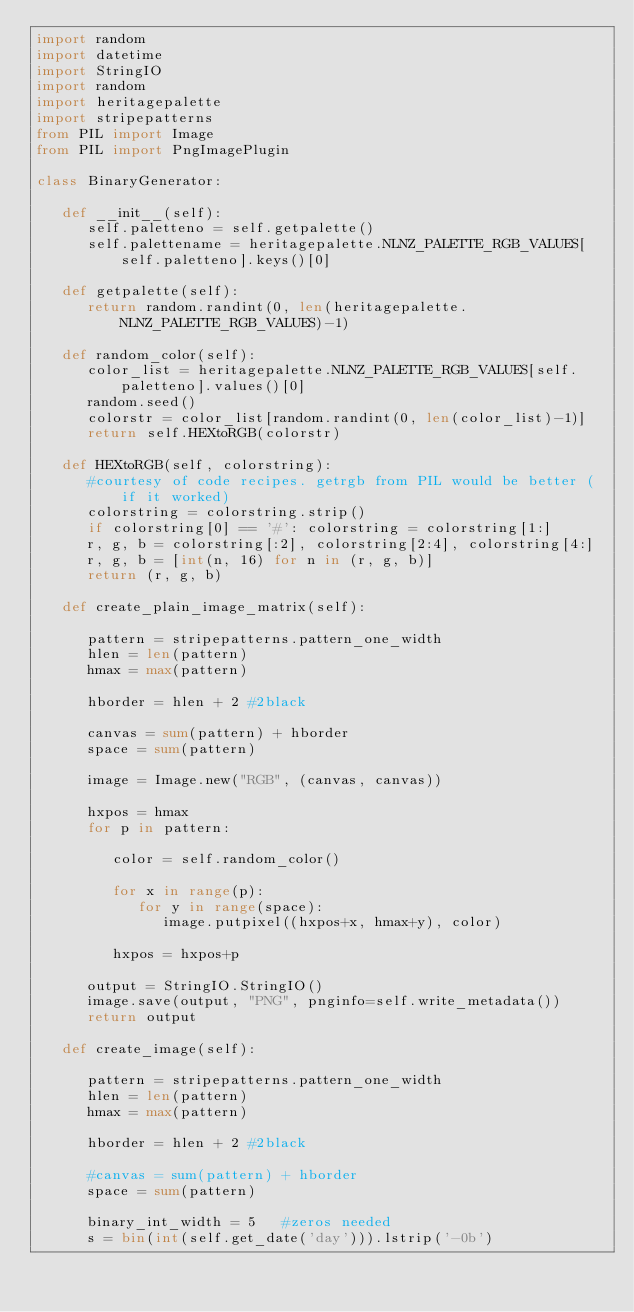Convert code to text. <code><loc_0><loc_0><loc_500><loc_500><_Python_>import random
import datetime
import StringIO
import random
import heritagepalette
import stripepatterns
from PIL import Image
from PIL import PngImagePlugin

class BinaryGenerator:

   def __init__(self):
      self.paletteno = self.getpalette()
      self.palettename = heritagepalette.NLNZ_PALETTE_RGB_VALUES[self.paletteno].keys()[0]

   def getpalette(self):
      return random.randint(0, len(heritagepalette.NLNZ_PALETTE_RGB_VALUES)-1)

   def random_color(self):
      color_list = heritagepalette.NLNZ_PALETTE_RGB_VALUES[self.paletteno].values()[0]
      random.seed()
      colorstr = color_list[random.randint(0, len(color_list)-1)]
      return self.HEXtoRGB(colorstr)

   def HEXtoRGB(self, colorstring):
      #courtesy of code recipes. getrgb from PIL would be better (if it worked)
      colorstring = colorstring.strip()
      if colorstring[0] == '#': colorstring = colorstring[1:]
      r, g, b = colorstring[:2], colorstring[2:4], colorstring[4:]
      r, g, b = [int(n, 16) for n in (r, g, b)]
      return (r, g, b)

   def create_plain_image_matrix(self):
      
      pattern = stripepatterns.pattern_one_width
      hlen = len(pattern)
      hmax = max(pattern) 

      hborder = hlen + 2 #2black

      canvas = sum(pattern) + hborder
      space = sum(pattern)

      image = Image.new("RGB", (canvas, canvas))

      hxpos = hmax
      for p in pattern:
       
         color = self.random_color()

         for x in range(p):
            for y in range(space):
               image.putpixel((hxpos+x, hmax+y), color)

         hxpos = hxpos+p

      output = StringIO.StringIO()
      image.save(output, "PNG", pnginfo=self.write_metadata())
      return output

   def create_image(self):
      
      pattern = stripepatterns.pattern_one_width
      hlen = len(pattern)
      hmax = max(pattern) 

      hborder = hlen + 2 #2black

      #canvas = sum(pattern) + hborder
      space = sum(pattern)

      binary_int_width = 5   #zeros needed
      s = bin(int(self.get_date('day'))).lstrip('-0b')</code> 